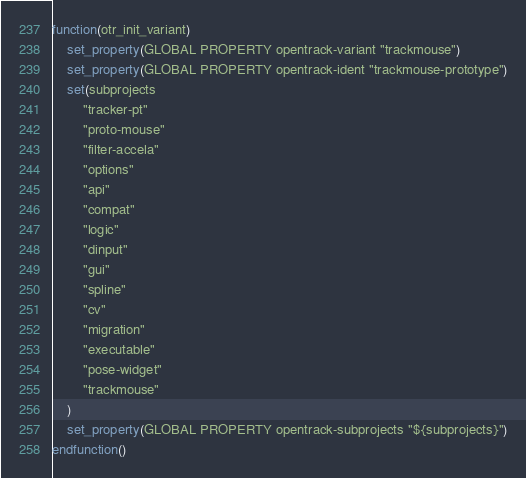Convert code to text. <code><loc_0><loc_0><loc_500><loc_500><_CMake_>function(otr_init_variant)
    set_property(GLOBAL PROPERTY opentrack-variant "trackmouse")
    set_property(GLOBAL PROPERTY opentrack-ident "trackmouse-prototype")
    set(subprojects
        "tracker-pt"
        "proto-mouse"
        "filter-accela"
        "options"
        "api"
        "compat"
        "logic"
        "dinput"
        "gui"
        "spline"
        "cv"
        "migration"
        "executable"
        "pose-widget"
        "trackmouse"
    )
    set_property(GLOBAL PROPERTY opentrack-subprojects "${subprojects}")
endfunction()
</code> 